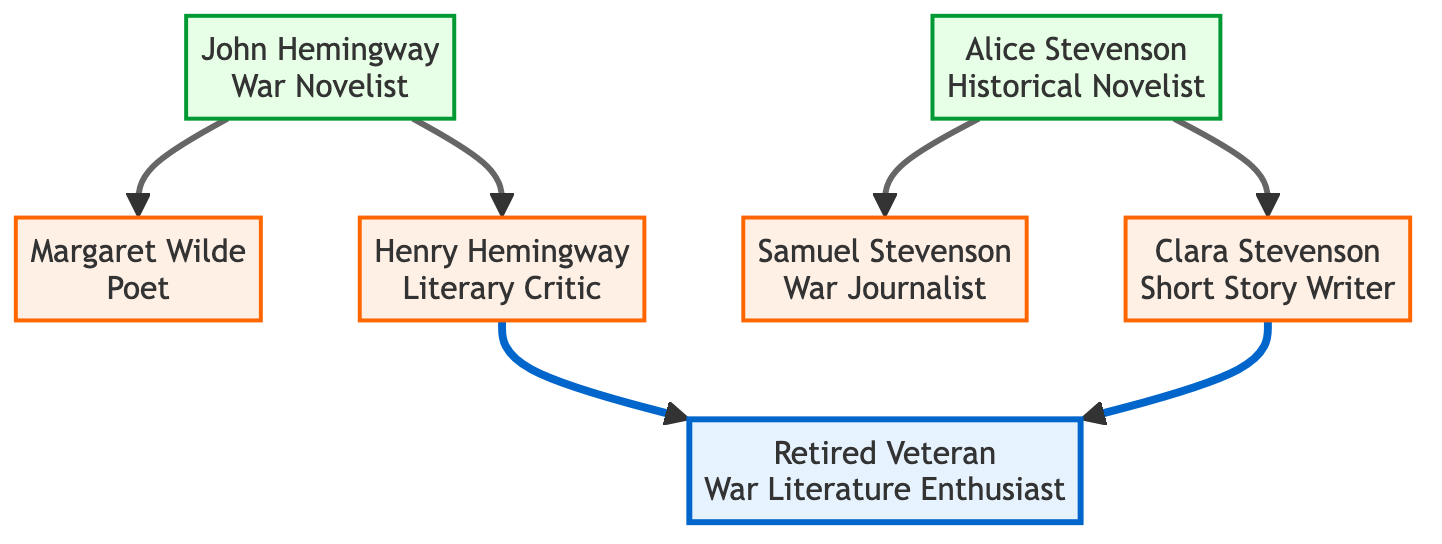What is the occupation of John Hemingway? From the diagram, John Hemingway is identified as a "War Novelist". This information is found in the label next to his node in the family tree.
Answer: War Novelist Who is the mother of Clara Stevenson? By looking at the relationships in the diagram, Clara Stevenson is the child of Alice Stevenson. This is indicated by the direct connection from Alice Stevenson to Clara Stevenson in the tree.
Answer: Alice Stevenson How many children does John Hemingway have? The diagram shows that John Hemingway has two children: Margaret Wilde and Henry Hemingway. This is evident from the branching relationship under John Hemingway's node.
Answer: 2 Which notable work is associated with Henry Hemingway? The diagram states that Henry Hemingway's notable work is "Journeys Through Conflict: Analyzing War Narratives." This title is mentioned directly in the description linked to his node.
Answer: Journeys Through Conflict: Analyzing War Narratives Which theme is explored by both John Hemingway and Alice Stevenson? By analyzing the themes explored in the works of John Hemingway ("war sacrifice", "combat trauma") and Alice Stevenson ("post-war recovery", "human endurance"), it is evident that while they explore different aspects of conflict, they both relate to the impact of war. However, they do not share a common theme. Thus, no themes can be stated as common between them.
Answer: None What is the occupation of Samuel Stevenson? The diagram clearly states that Samuel Stevenson is a "War Journalist". This information is available right next to his node in the family tree structure.
Answer: War Journalist How does the theme of human resilience appear in the family lineage? The diagram indicates that both Margaret Wilde, a poet, explores "human resilience" in her work "Verses Under Fire", and Alice Stevenson, a historical novelist, covers themes of "post-war recovery" and "human endurance". This demonstrates a shared emphasis on resilience across generations.
Answer: Margaret Wilde and Alice Stevenson Who is listed as the War Literature Enthusiast? The family tree shows that there are two references to the "Retired Veteran", both as a child of Henry Hemingway and Clara Stevenson, and directly within the main node. This indicates the presence of the War Literature Enthusiast in two parts of the lineage.
Answer: Retired Veteran What themes does Clara Stevenson explore in her writing? According to the diagram, Clara Stevenson explores themes of "everyday heroism" and "family in wartime," which are listed in the description linked to her node.
Answer: Everyday heroism, family in wartime 